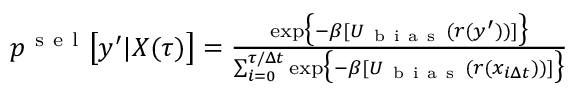<formula> <loc_0><loc_0><loc_500><loc_500>\begin{array} { r } { p ^ { s e l } \left [ y ^ { \prime } | X ( \tau ) \right ] = \frac { \exp \left \{ - \beta [ U _ { b i a s } ( r ( y ^ { \prime } ) ) ] \right \} } { \sum _ { i = 0 } ^ { \tau / \Delta t } \exp \left \{ - \beta [ U _ { b i a s } ( r ( x _ { i \Delta t } ) ) ] \right \} } } \end{array}</formula> 